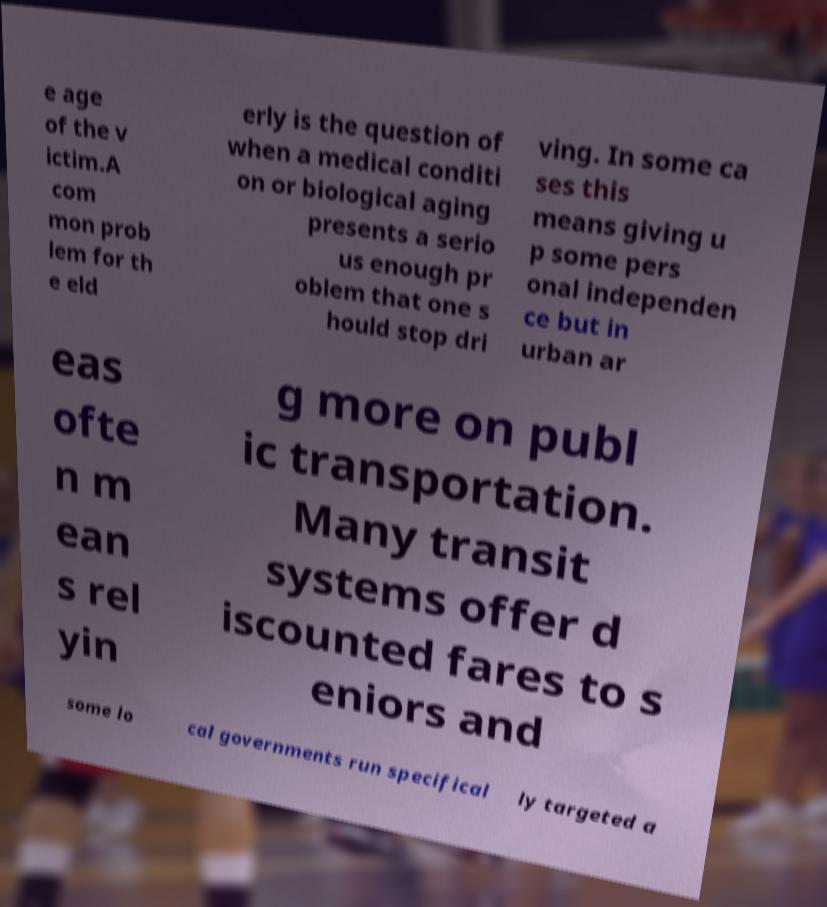Please read and relay the text visible in this image. What does it say? e age of the v ictim.A com mon prob lem for th e eld erly is the question of when a medical conditi on or biological aging presents a serio us enough pr oblem that one s hould stop dri ving. In some ca ses this means giving u p some pers onal independen ce but in urban ar eas ofte n m ean s rel yin g more on publ ic transportation. Many transit systems offer d iscounted fares to s eniors and some lo cal governments run specifical ly targeted a 